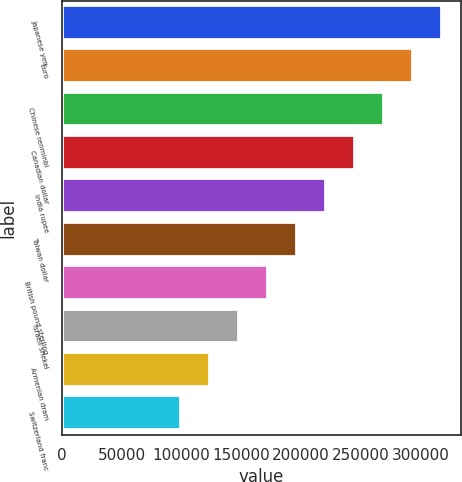Convert chart to OTSL. <chart><loc_0><loc_0><loc_500><loc_500><bar_chart><fcel>Japanese yen<fcel>Euro<fcel>Chinese renminbi<fcel>Canadian dollar<fcel>India rupee<fcel>Taiwan dollar<fcel>British pound sterling<fcel>Israeli shekel<fcel>Armenian dram<fcel>Switzerland franc<nl><fcel>318077<fcel>293837<fcel>269597<fcel>245357<fcel>221117<fcel>196877<fcel>172637<fcel>148397<fcel>124158<fcel>99917.6<nl></chart> 